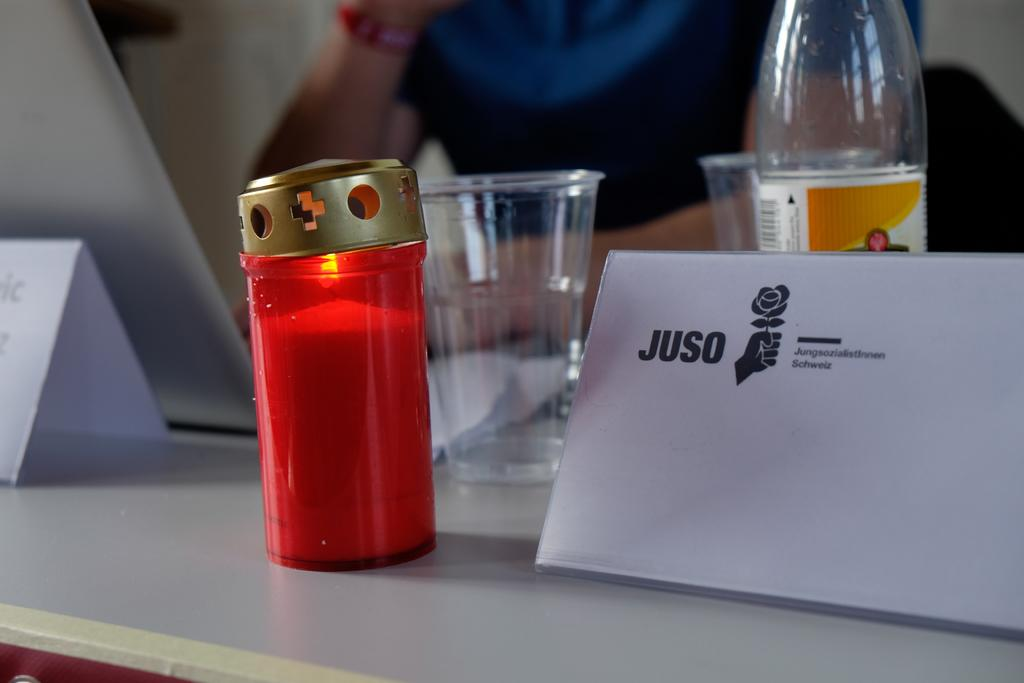<image>
Provide a brief description of the given image. an envelope leaning on a bottle that is labeled 'juso' 